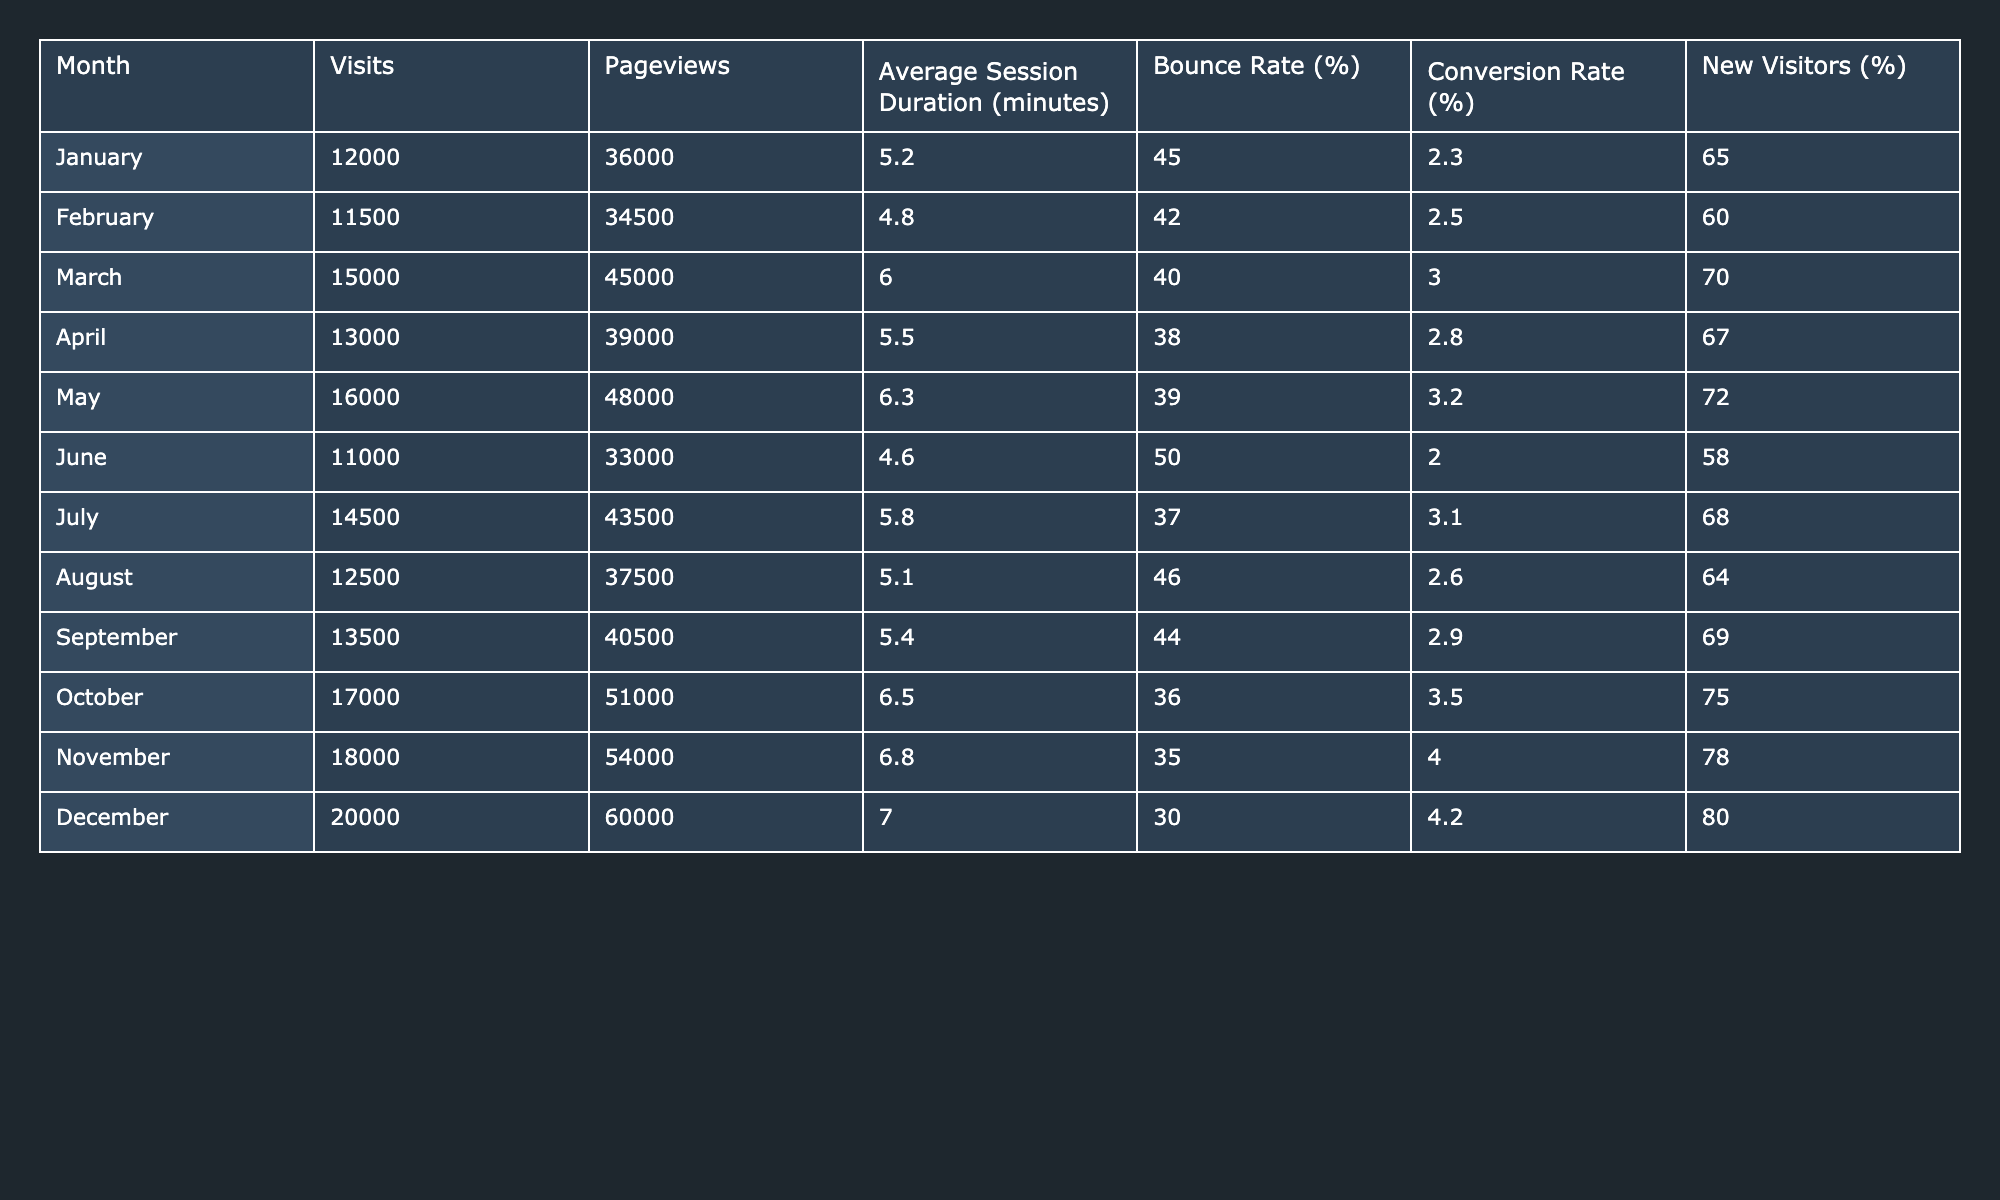What was the total number of visits in December? The table shows that the total number of visits in December is 20,000.
Answer: 20,000 What is the average session duration for July? The table states that the average session duration for July is 5.8 minutes.
Answer: 5.8 Which month had the highest conversion rate? December had the highest conversion rate of 4.2%.
Answer: 4.2% What was the bounce rate in March? According to the table, the bounce rate in March was 40%.
Answer: 40% In which month did the conversion rate exceed 3% for the first time? The conversion rate exceeded 3% for the first time in March, when it reached 3.0%.
Answer: March What is the difference in bounce rate between November and December? The bounce rate in November is 35%, while in December it is 30%. The difference is 35 - 30 = 5%.
Answer: 5% What was the total number of new visitors in the first quarter (January to March)? The new visitors percentages for January, February, and March are 65%, 60%, and 70% respectively. To find the total, we take: (12,000 * 0.65) + (11,500 * 0.60) + (15,000 * 0.70) = 7,800 + 6,900 + 10,500 = 25,200 new visitors.
Answer: 25,200 Which month had the lowest average session duration? June had the lowest average session duration at 4.6 minutes.
Answer: 4.6 minutes What is the average bounce rate for the second half of the year (July to December)? The bounce rates for July to December are 37, 46, 44, 36, 35, and 30 respectively. The average bounce rate is (37 + 46 + 44 + 36 + 35 + 30) / 6 = 36.
Answer: 36 Did more new visitors come in December compared to January? Yes, December had 80% new visitors, while January had 65%. Therefore, December had more new visitors.
Answer: Yes How much did the total pageviews change from August to October? August had 37,500 pageviews and October had 51,000 pageviews. The change is 51,000 - 37,500 = 13,500 additional pageviews from August to October.
Answer: 13,500 In which month was the average session duration the highest? The highest average session duration was in December at 7.0 minutes.
Answer: 7.0 minutes What percentage of visitors were new in May? The percentage of new visitors in May was 72%.
Answer: 72% If we sum the visits for April through June, what is the total? The visits for April (13,000), May (16,000), and June (11,000) total to 13,000 + 16,000 + 11,000 = 40,000 visits.
Answer: 40,000 